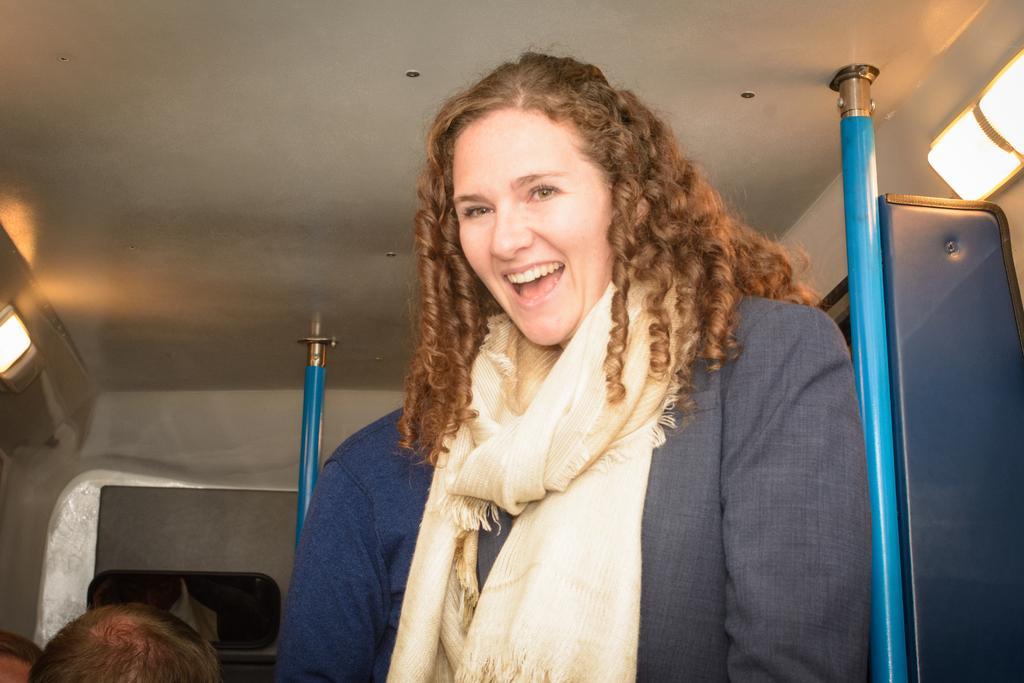In one or two sentences, can you explain what this image depicts? Here we can see a woman and she is smiling. In the background there are rods and lights. 